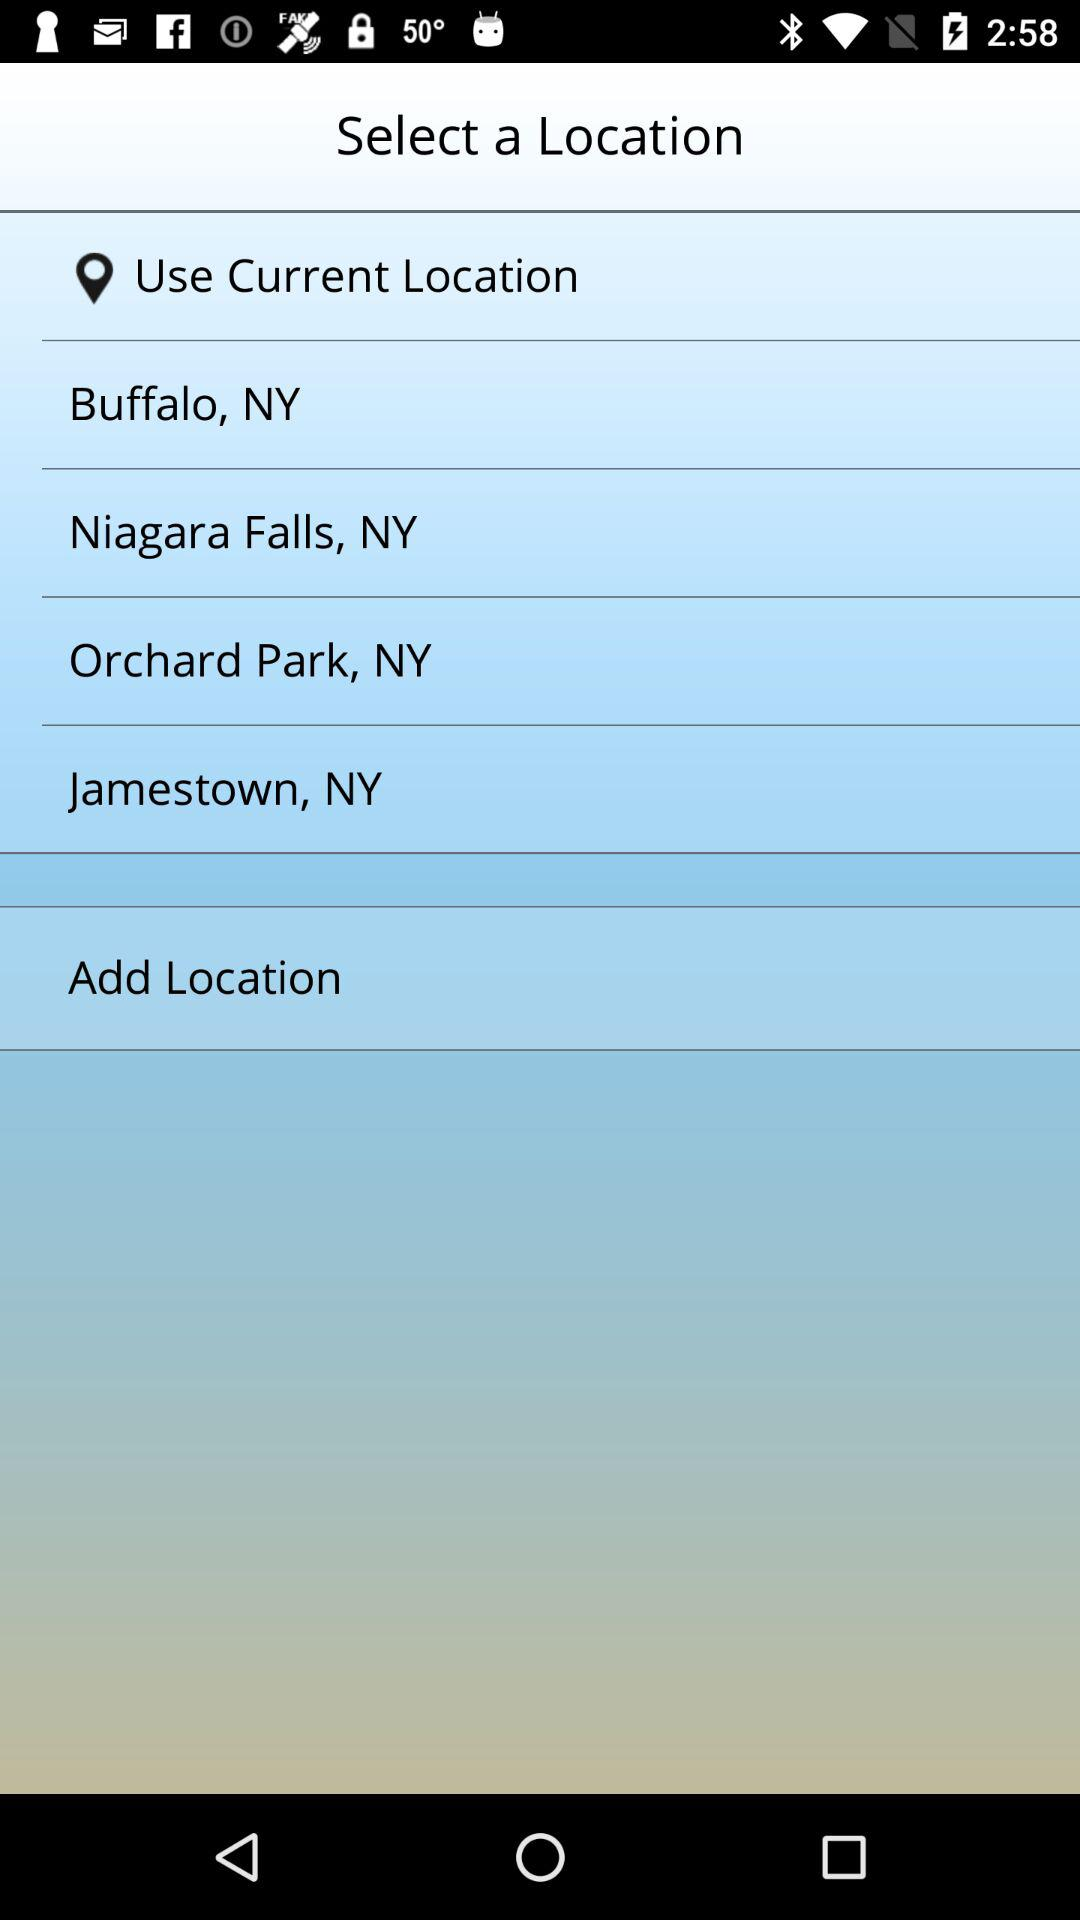How many locations are there to choose from?
Answer the question using a single word or phrase. 5 